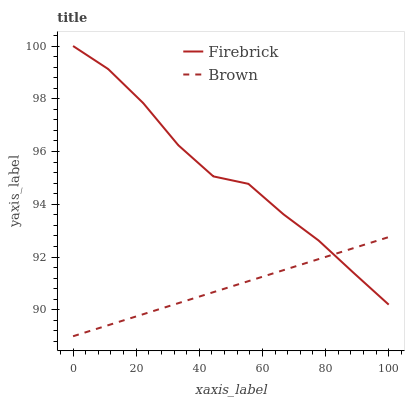Does Brown have the minimum area under the curve?
Answer yes or no. Yes. Does Firebrick have the maximum area under the curve?
Answer yes or no. Yes. Does Firebrick have the minimum area under the curve?
Answer yes or no. No. Is Brown the smoothest?
Answer yes or no. Yes. Is Firebrick the roughest?
Answer yes or no. Yes. Is Firebrick the smoothest?
Answer yes or no. No. Does Brown have the lowest value?
Answer yes or no. Yes. Does Firebrick have the lowest value?
Answer yes or no. No. Does Firebrick have the highest value?
Answer yes or no. Yes. Does Brown intersect Firebrick?
Answer yes or no. Yes. Is Brown less than Firebrick?
Answer yes or no. No. Is Brown greater than Firebrick?
Answer yes or no. No. 